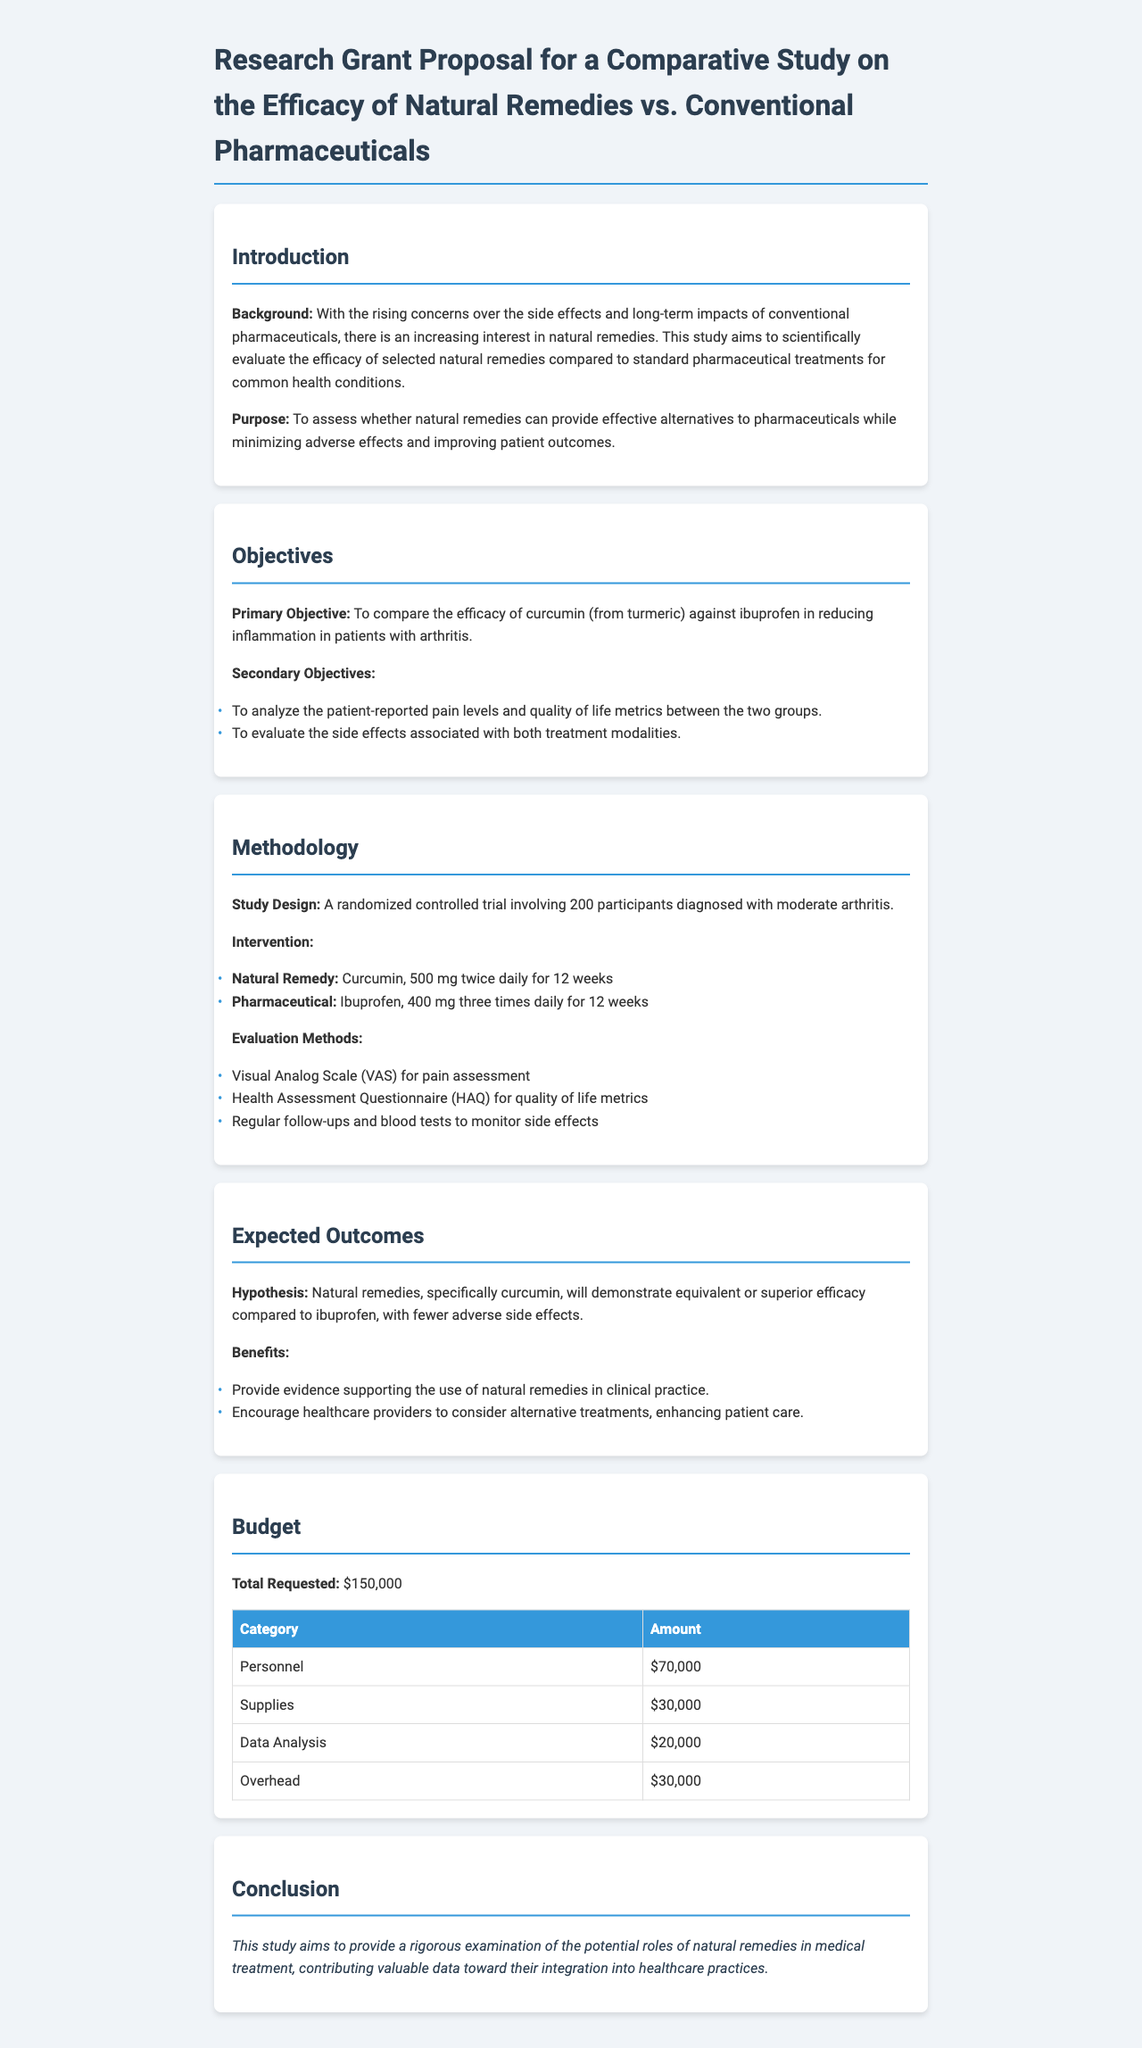What is the primary objective of the study? The primary objective of the study is to compare the efficacy of curcumin against ibuprofen in reducing inflammation in patients with arthritis.
Answer: Compare the efficacy of curcumin against ibuprofen in reducing inflammation in patients with arthritis What is the total amount requested for the budget? The total amount requested for the budget is stated in the budget section of the document.
Answer: $150,000 Which natural remedy is being examined in this study? The natural remedy being examined is specified in the objectives section of the document.
Answer: Curcumin How many participants will be involved in the study? The number of participants is mentioned in the methodology section regarding the study design.
Answer: 200 participants What assessment tool will be used for pain levels? The assessment tool for pain levels is mentioned in the evaluation methods of the methodology section.
Answer: Visual Analog Scale (VAS) What are the expected benefits of the study? The expected benefits entail the potential implications of the study's findings as outlined in the expected outcomes section.
Answer: Provide evidence supporting the use of natural remedies in clinical practice What is the budget category with the highest amount? The highest budget category is found by comparing the amounts listed in the budget table.
Answer: Personnel What type of study design is being used? The type of study design is described in the methodology section.
Answer: Randomized controlled trial 